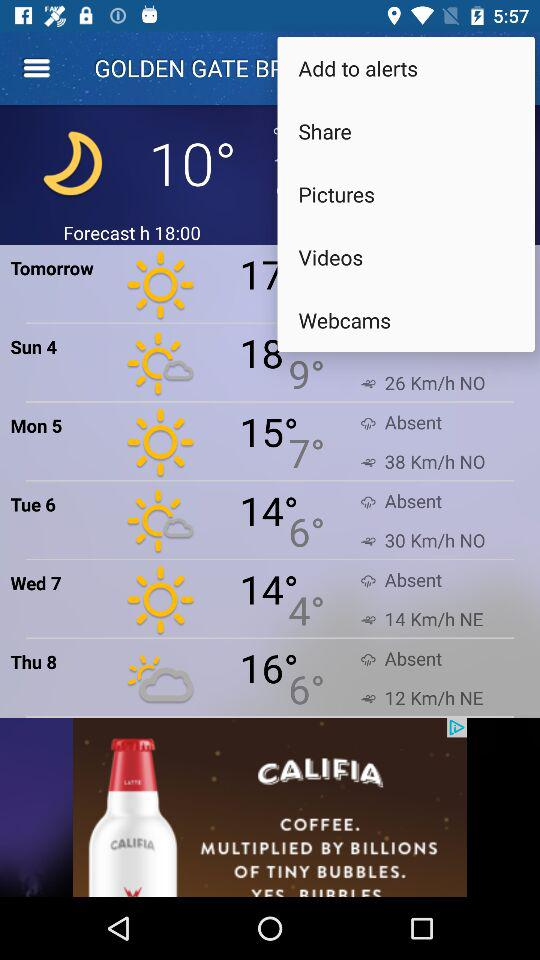What will be the minimum temperature on Monday, 5? The minimum temperature will be 7°. 